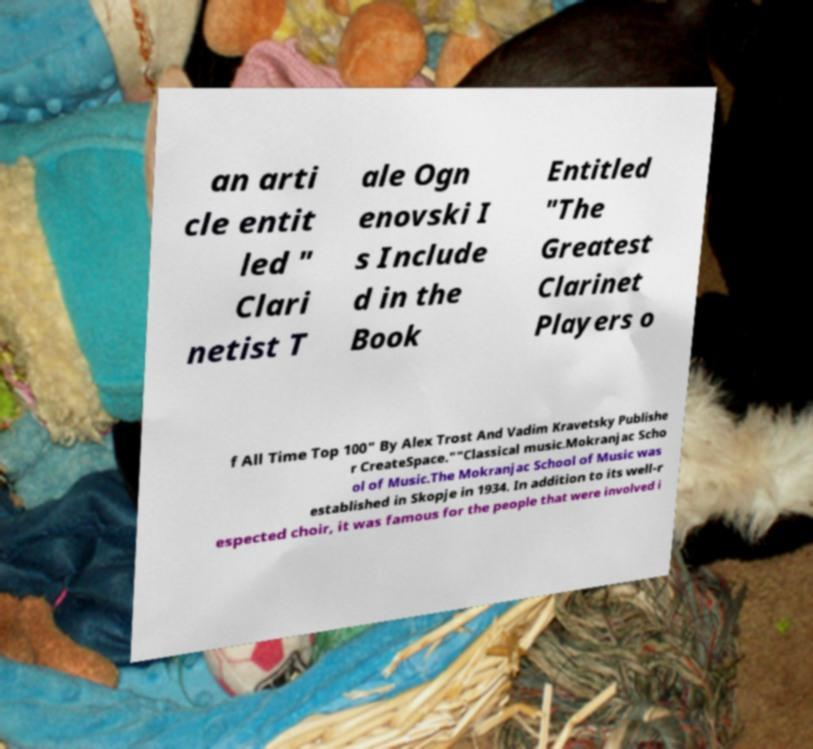Could you extract and type out the text from this image? an arti cle entit led " Clari netist T ale Ogn enovski I s Include d in the Book Entitled "The Greatest Clarinet Players o f All Time Top 100" By Alex Trost And Vadim Kravetsky Publishe r CreateSpace.""Classical music.Mokranjac Scho ol of Music.The Mokranjac School of Music was established in Skopje in 1934. In addition to its well-r espected choir, it was famous for the people that were involved i 